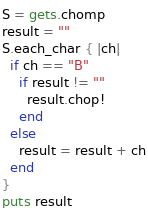Convert code to text. <code><loc_0><loc_0><loc_500><loc_500><_Ruby_>S = gets.chomp
result = ""
S.each_char { |ch|
  if ch == "B"
    if result != ""
      result.chop!
    end
  else
    result = result + ch
  end
}
puts result
</code> 